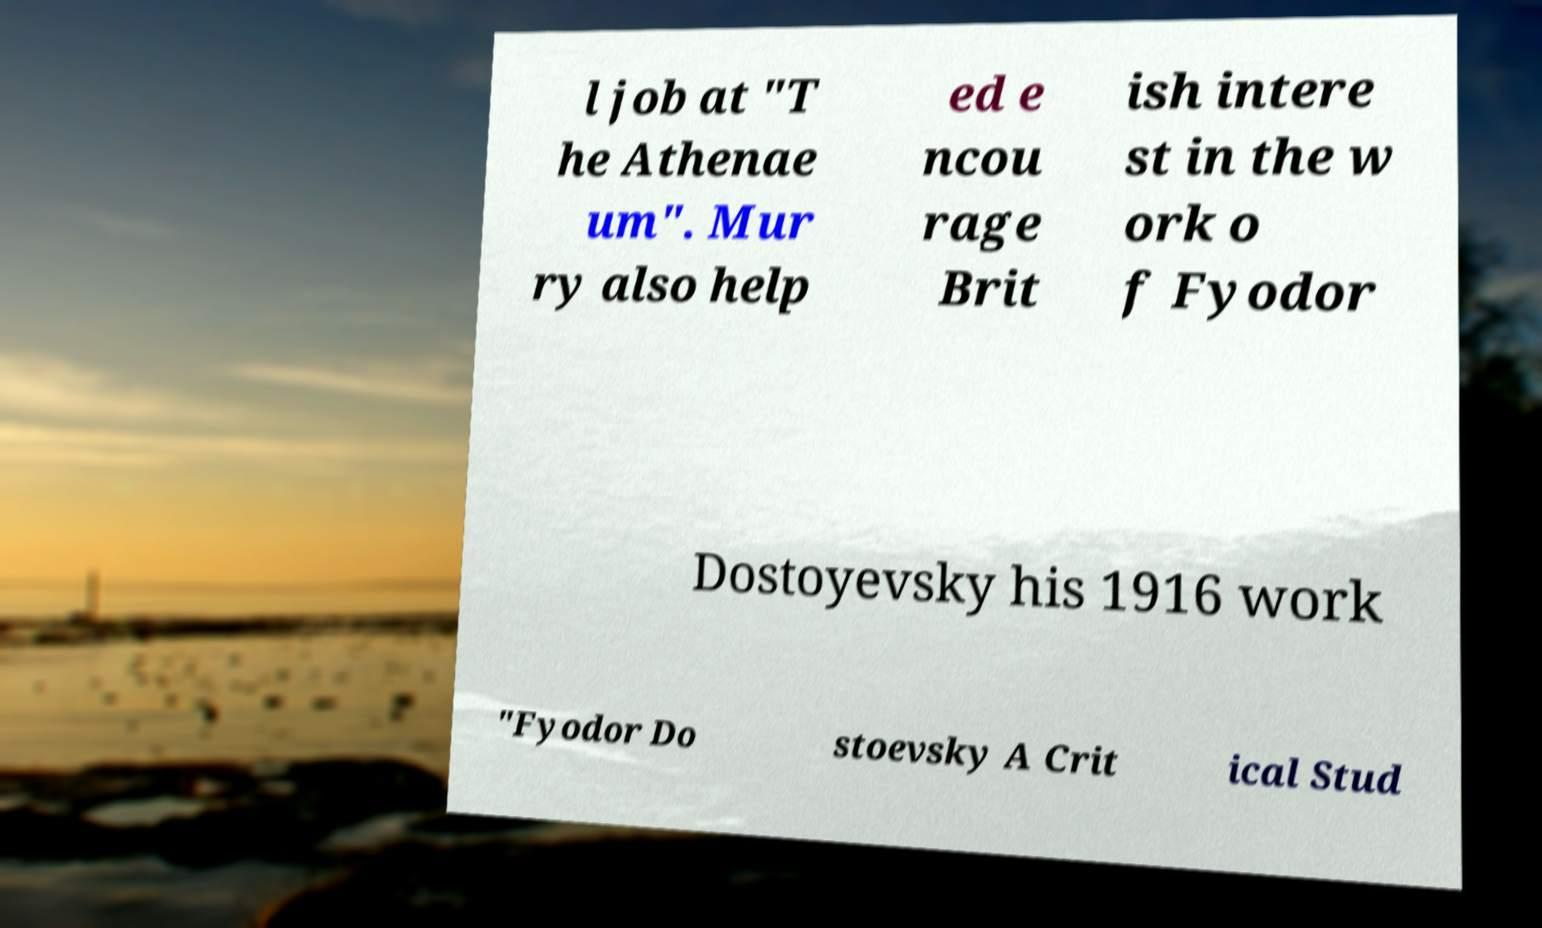There's text embedded in this image that I need extracted. Can you transcribe it verbatim? l job at "T he Athenae um". Mur ry also help ed e ncou rage Brit ish intere st in the w ork o f Fyodor Dostoyevsky his 1916 work "Fyodor Do stoevsky A Crit ical Stud 